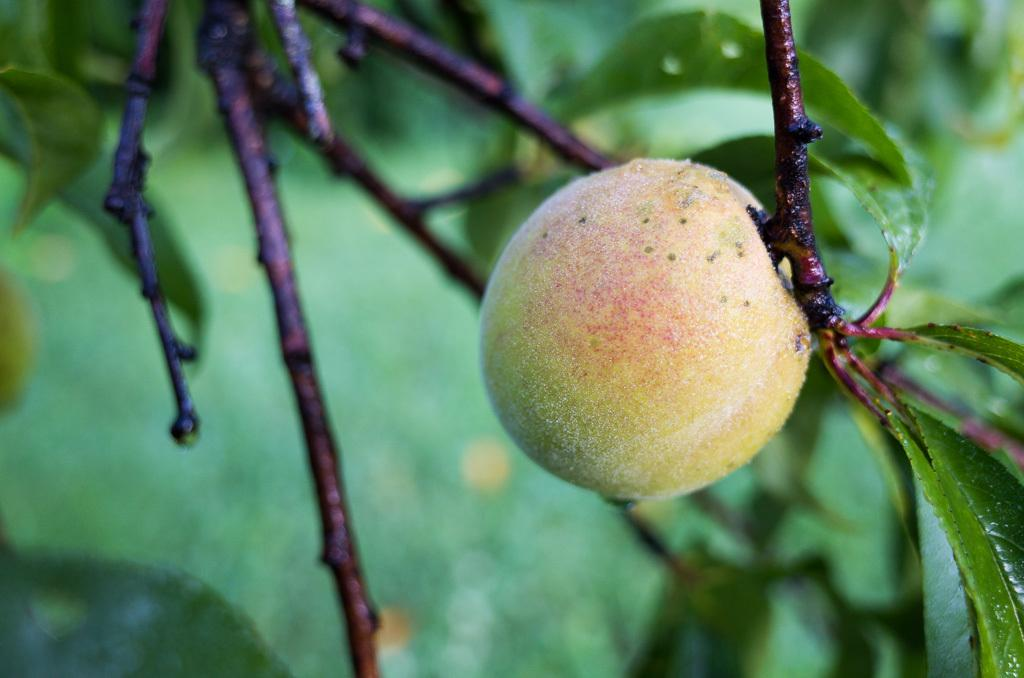What is present in the image that is a living organism? There is a plant in the image. What is the plant producing? The plant has a fruit. What can be seen in the background of the image? There are leaves in the background of the image. What is the condition of the leaves? The leaves have droplets of water on them. What is visible on the left side of the image? There are tree stems on the left side of the image. What type of screw is holding the doll's arm in place in the image? There is no doll or screw present in the image; it features a plant with a fruit, leaves with droplets of water, and tree stems. 